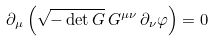<formula> <loc_0><loc_0><loc_500><loc_500>\partial _ { \mu } \left ( \sqrt { - \det G } \, G ^ { \mu \nu } \, \partial _ { \nu } \varphi \right ) = 0</formula> 